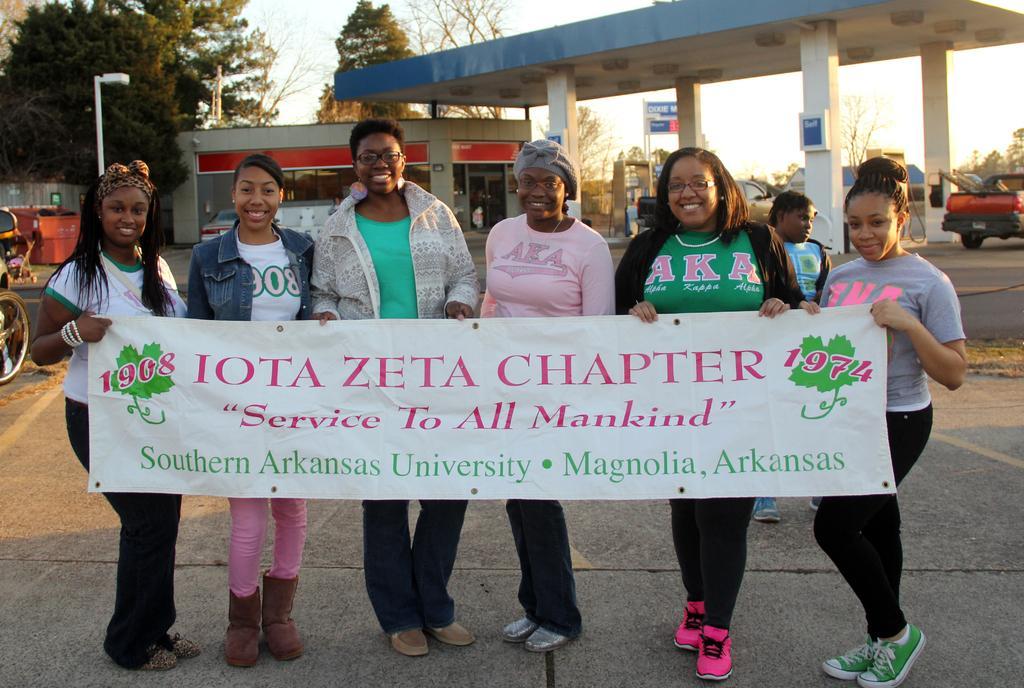Can you describe this image briefly? In this picture there is a group of African girls standing and holding a white banner in the hand, smiling and giving a pose into the camera. Behind there is a petrol bunk, red color car and some trees on the left side. 